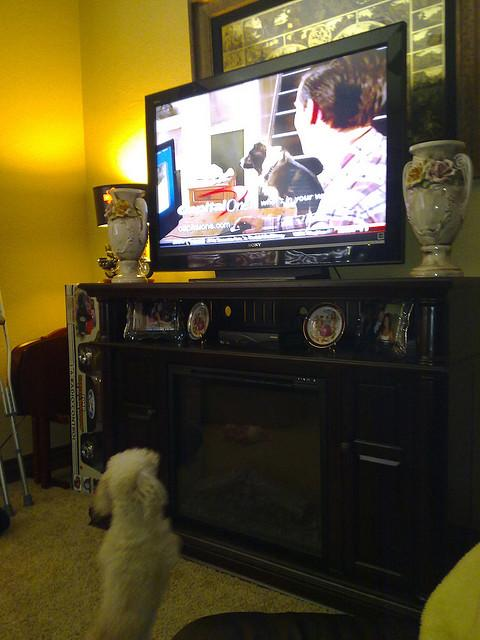What does this dog like on the TV? another dog 